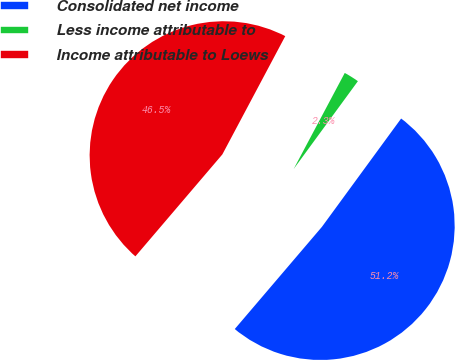Convert chart to OTSL. <chart><loc_0><loc_0><loc_500><loc_500><pie_chart><fcel>Consolidated net income<fcel>Less income attributable to<fcel>Income attributable to Loews<nl><fcel>51.19%<fcel>2.27%<fcel>46.54%<nl></chart> 